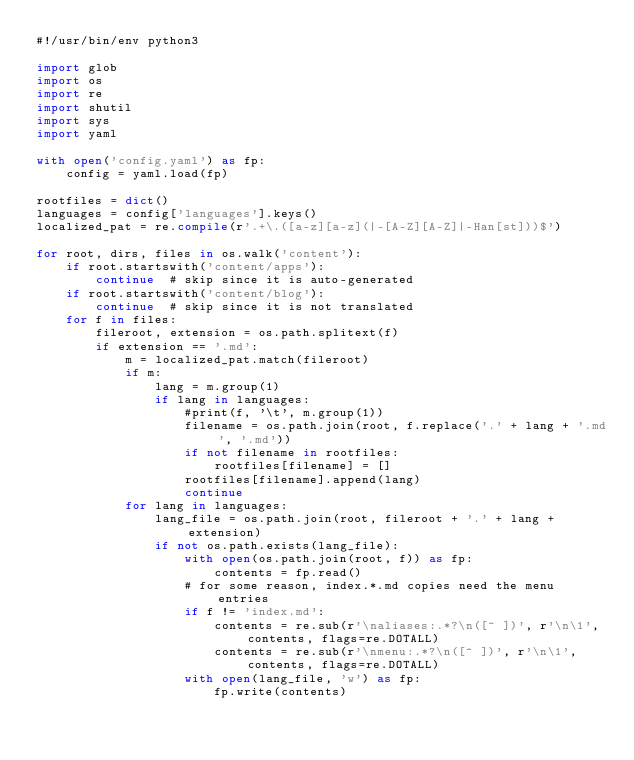<code> <loc_0><loc_0><loc_500><loc_500><_Python_>#!/usr/bin/env python3

import glob
import os
import re
import shutil
import sys
import yaml

with open('config.yaml') as fp:
    config = yaml.load(fp)

rootfiles = dict()
languages = config['languages'].keys()
localized_pat = re.compile(r'.+\.([a-z][a-z](|-[A-Z][A-Z]|-Han[st]))$')

for root, dirs, files in os.walk('content'):
    if root.startswith('content/apps'):
        continue  # skip since it is auto-generated
    if root.startswith('content/blog'):
        continue  # skip since it is not translated
    for f in files:
        fileroot, extension = os.path.splitext(f)
        if extension == '.md':
            m = localized_pat.match(fileroot)
            if m:
                lang = m.group(1)
                if lang in languages:
                    #print(f, '\t', m.group(1))
                    filename = os.path.join(root, f.replace('.' + lang + '.md', '.md'))
                    if not filename in rootfiles:
                        rootfiles[filename] = []
                    rootfiles[filename].append(lang)
                    continue
            for lang in languages:
                lang_file = os.path.join(root, fileroot + '.' + lang + extension)
                if not os.path.exists(lang_file):
                    with open(os.path.join(root, f)) as fp:
                        contents = fp.read()
                    # for some reason, index.*.md copies need the menu entries
                    if f != 'index.md':
                        contents = re.sub(r'\naliases:.*?\n([^ ])', r'\n\1', contents, flags=re.DOTALL)
                        contents = re.sub(r'\nmenu:.*?\n([^ ])', r'\n\1', contents, flags=re.DOTALL)
                    with open(lang_file, 'w') as fp:
                        fp.write(contents)
</code> 